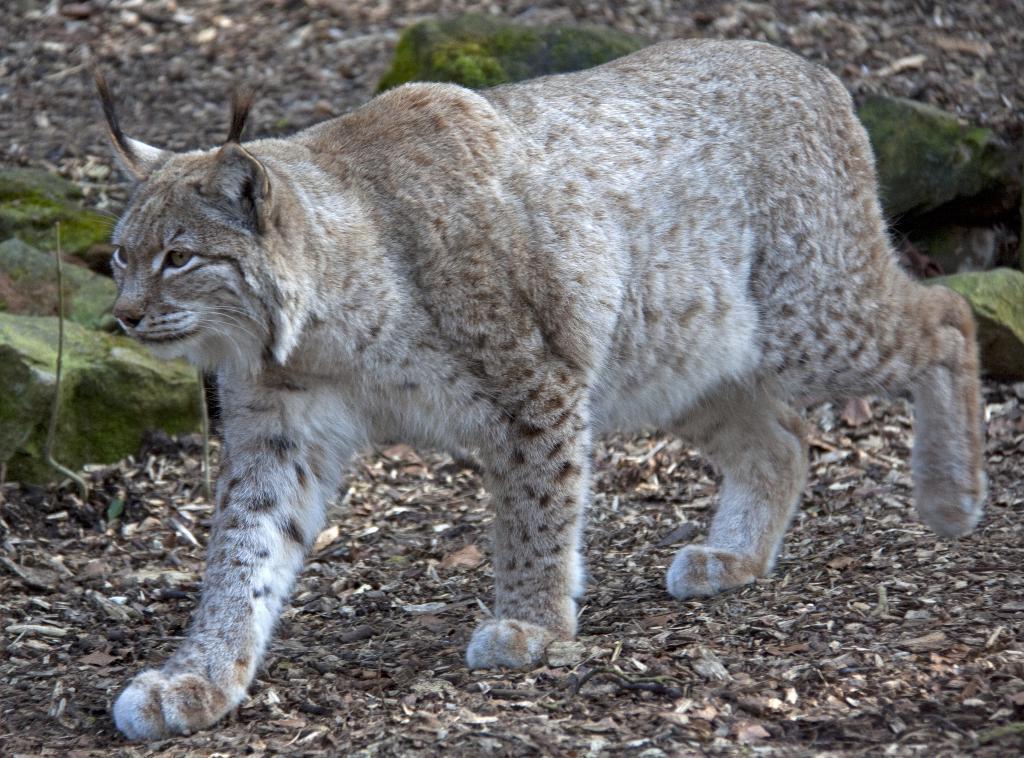Describe this image in one or two sentences. In this picture there is a wild which is walking on the ground. Beside that I can see the stones and leaves. 